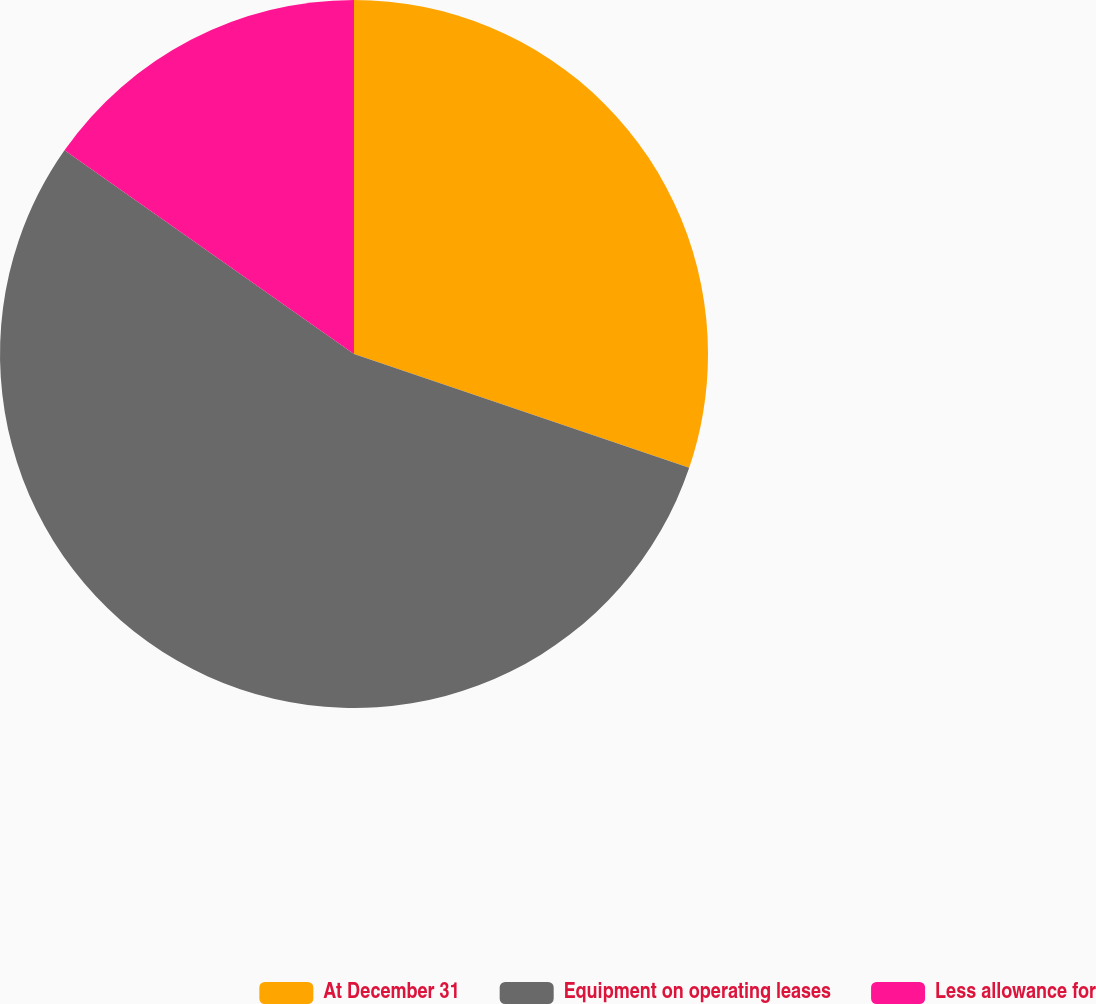<chart> <loc_0><loc_0><loc_500><loc_500><pie_chart><fcel>At December 31<fcel>Equipment on operating leases<fcel>Less allowance for<nl><fcel>30.21%<fcel>54.55%<fcel>15.24%<nl></chart> 